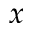Convert formula to latex. <formula><loc_0><loc_0><loc_500><loc_500>x</formula> 